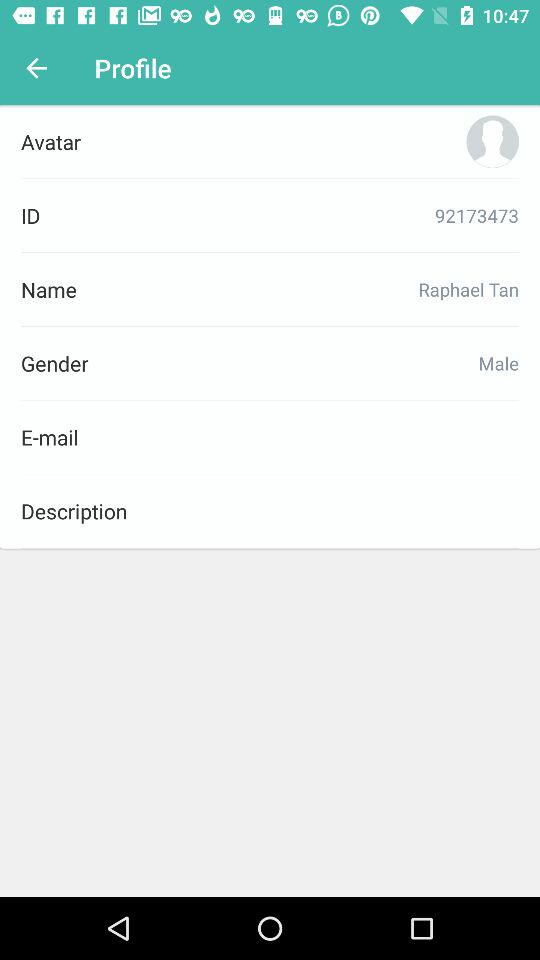How many fields does the profile page have?
Answer the question using a single word or phrase. 6 